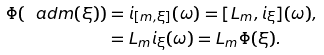Convert formula to latex. <formula><loc_0><loc_0><loc_500><loc_500>\Phi ( \ a d m ( \xi ) ) & = i _ { [ m , \xi ] } ( \omega ) = [ L _ { m } , i _ { \xi } ] ( \omega ) , \\ & = L _ { m } i _ { \xi } ( \omega ) = L _ { m } \Phi ( \xi ) . \\</formula> 